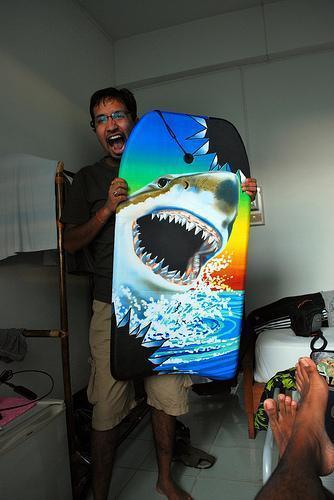How many surfboards are there?
Give a very brief answer. 1. 